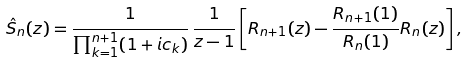<formula> <loc_0><loc_0><loc_500><loc_500>\hat { S } _ { n } ( z ) = \frac { 1 } { \prod _ { k = 1 } ^ { n + 1 } ( 1 + i c _ { k } ) } \, \frac { 1 } { z - 1 } \left [ R _ { n + 1 } ( z ) - \frac { R _ { n + 1 } ( 1 ) } { R _ { n } ( 1 ) } R _ { n } ( z ) \right ] ,</formula> 